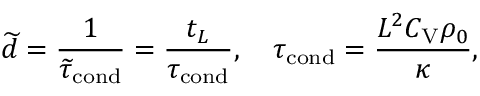Convert formula to latex. <formula><loc_0><loc_0><loc_500><loc_500>\widetilde { d } = \frac { 1 } { \widetilde { \tau } _ { c o n d } } = \frac { t _ { L } } { \tau _ { c o n d } } , \quad \tau _ { c o n d } = \frac { L ^ { 2 } C _ { V } \rho _ { 0 } } { \kappa } ,</formula> 